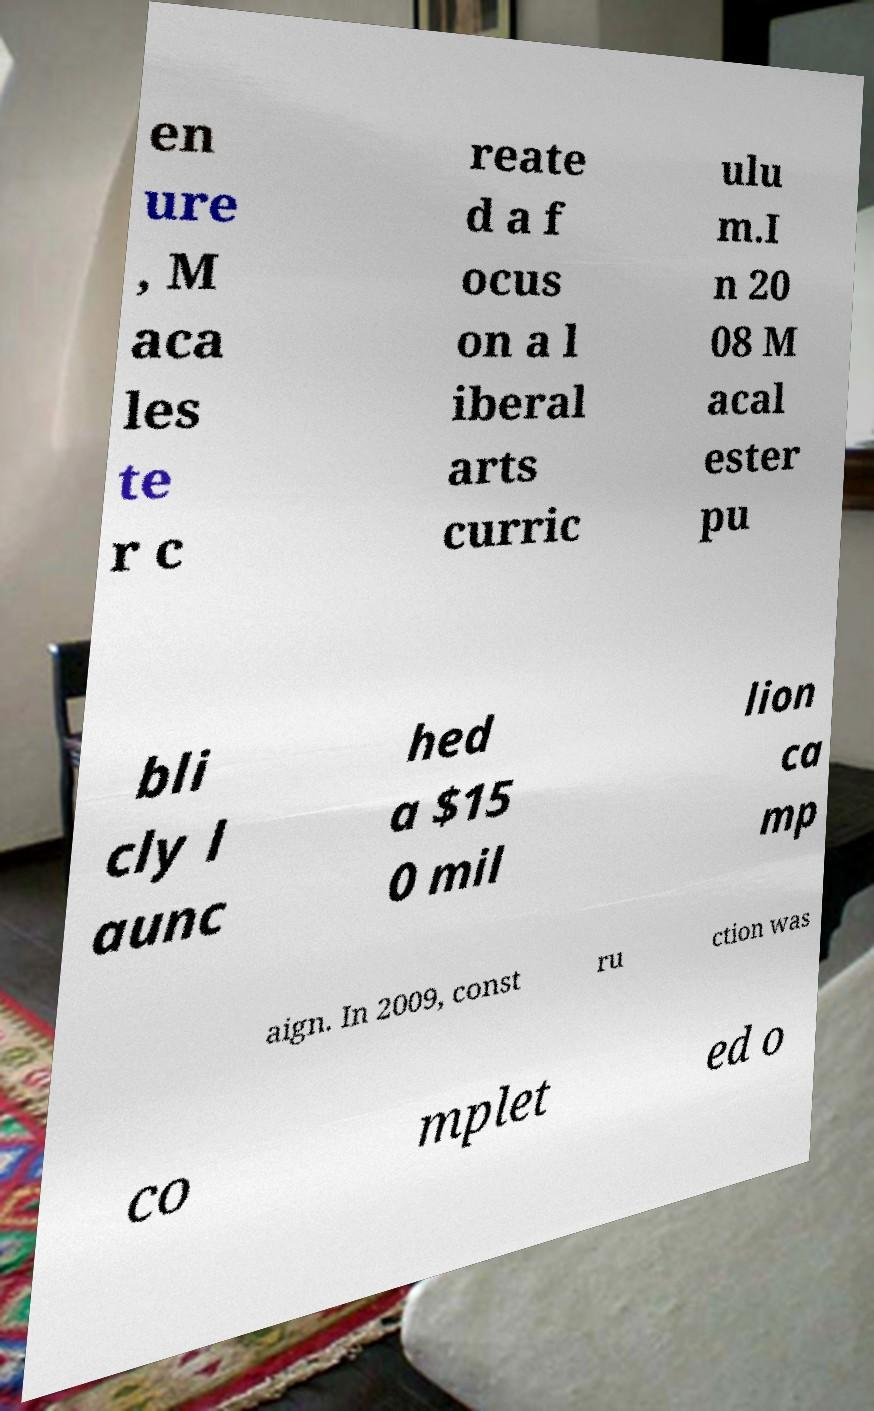Please read and relay the text visible in this image. What does it say? en ure , M aca les te r c reate d a f ocus on a l iberal arts curric ulu m.I n 20 08 M acal ester pu bli cly l aunc hed a $15 0 mil lion ca mp aign. In 2009, const ru ction was co mplet ed o 